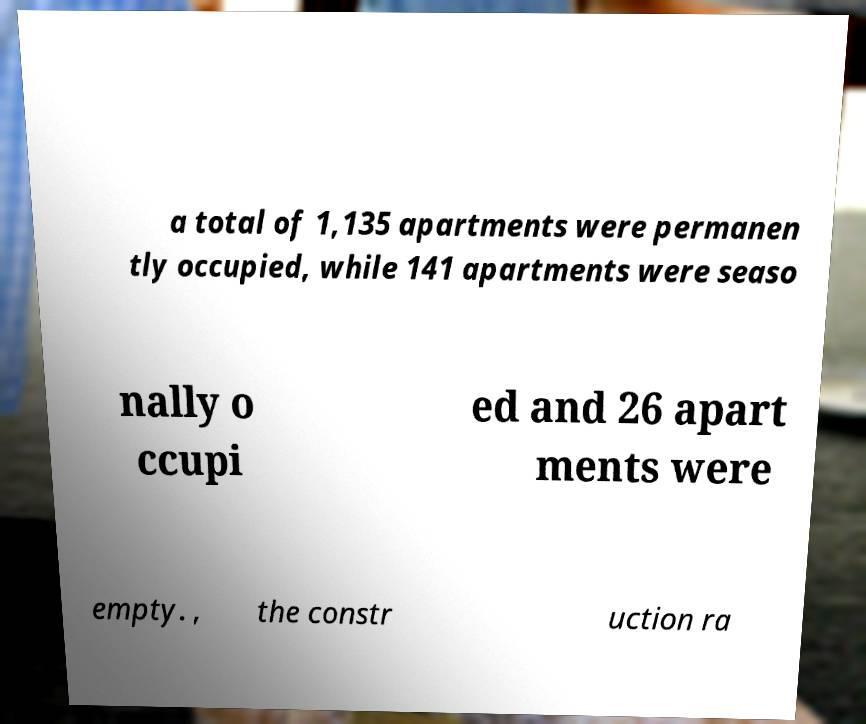Could you extract and type out the text from this image? a total of 1,135 apartments were permanen tly occupied, while 141 apartments were seaso nally o ccupi ed and 26 apart ments were empty. , the constr uction ra 